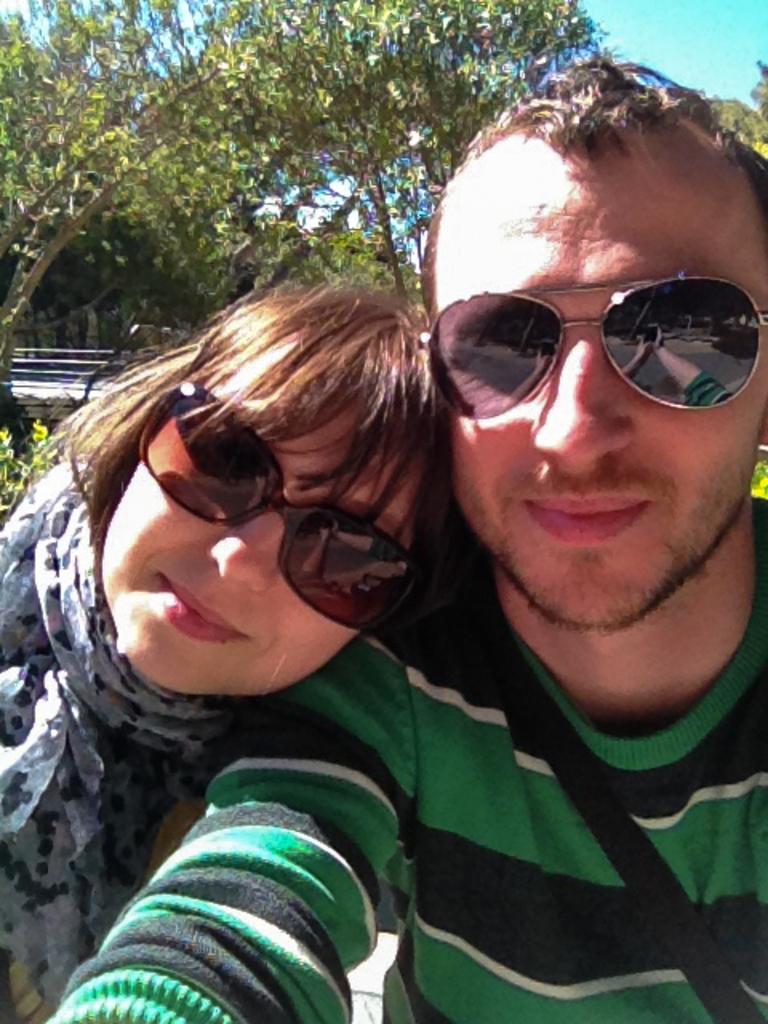Please provide a concise description of this image. In the foreground of this picture we can see the two persons wearing goggles. In the background we can see the sky, trees and some other objects. 